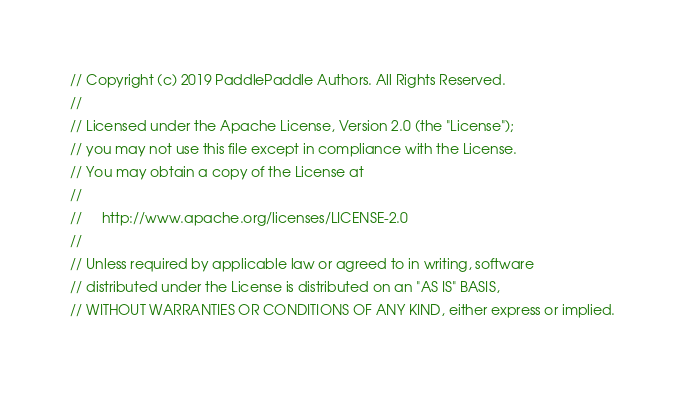<code> <loc_0><loc_0><loc_500><loc_500><_C++_>// Copyright (c) 2019 PaddlePaddle Authors. All Rights Reserved.
//
// Licensed under the Apache License, Version 2.0 (the "License");
// you may not use this file except in compliance with the License.
// You may obtain a copy of the License at
//
//     http://www.apache.org/licenses/LICENSE-2.0
//
// Unless required by applicable law or agreed to in writing, software
// distributed under the License is distributed on an "AS IS" BASIS,
// WITHOUT WARRANTIES OR CONDITIONS OF ANY KIND, either express or implied.</code> 